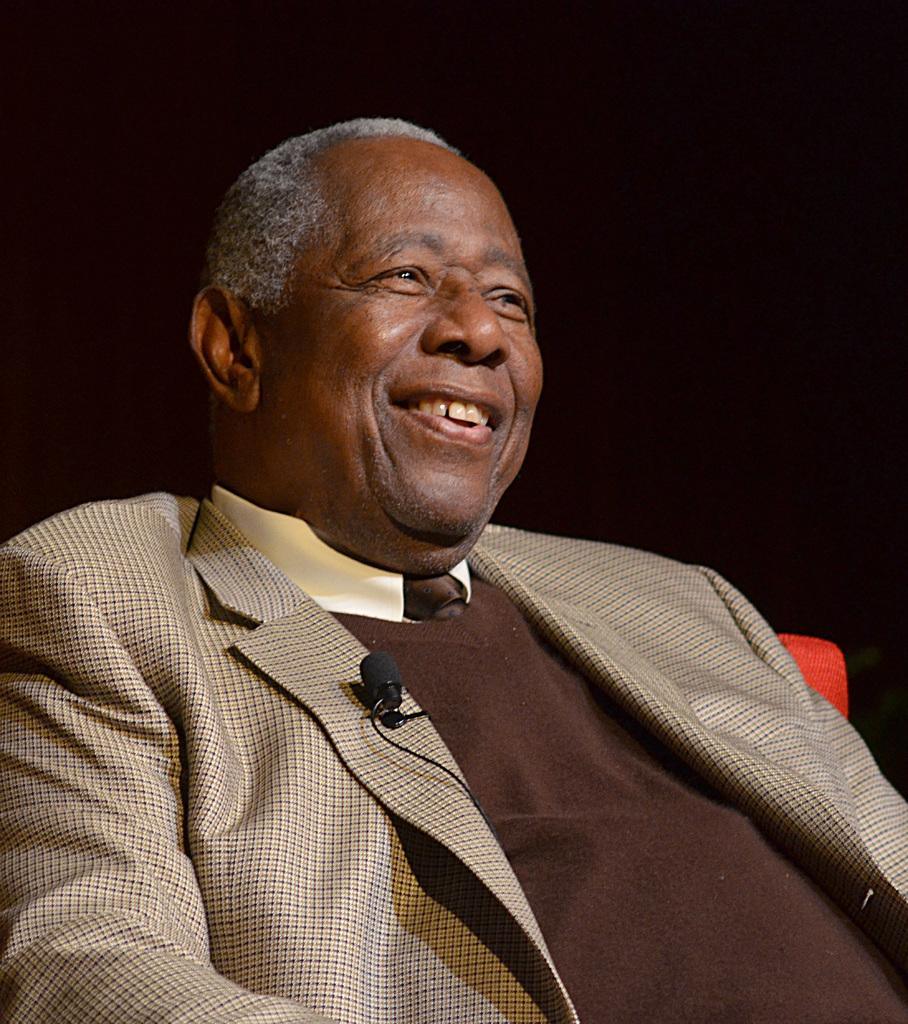Who is present in the image? There is a man in the image. What is the man doing in the image? The man is laughing. What can be observed about the background of the image? The background of the image is dark. What street is the man walking on in the image? There is no street present in the image, as it only features a man laughing against a dark background. 